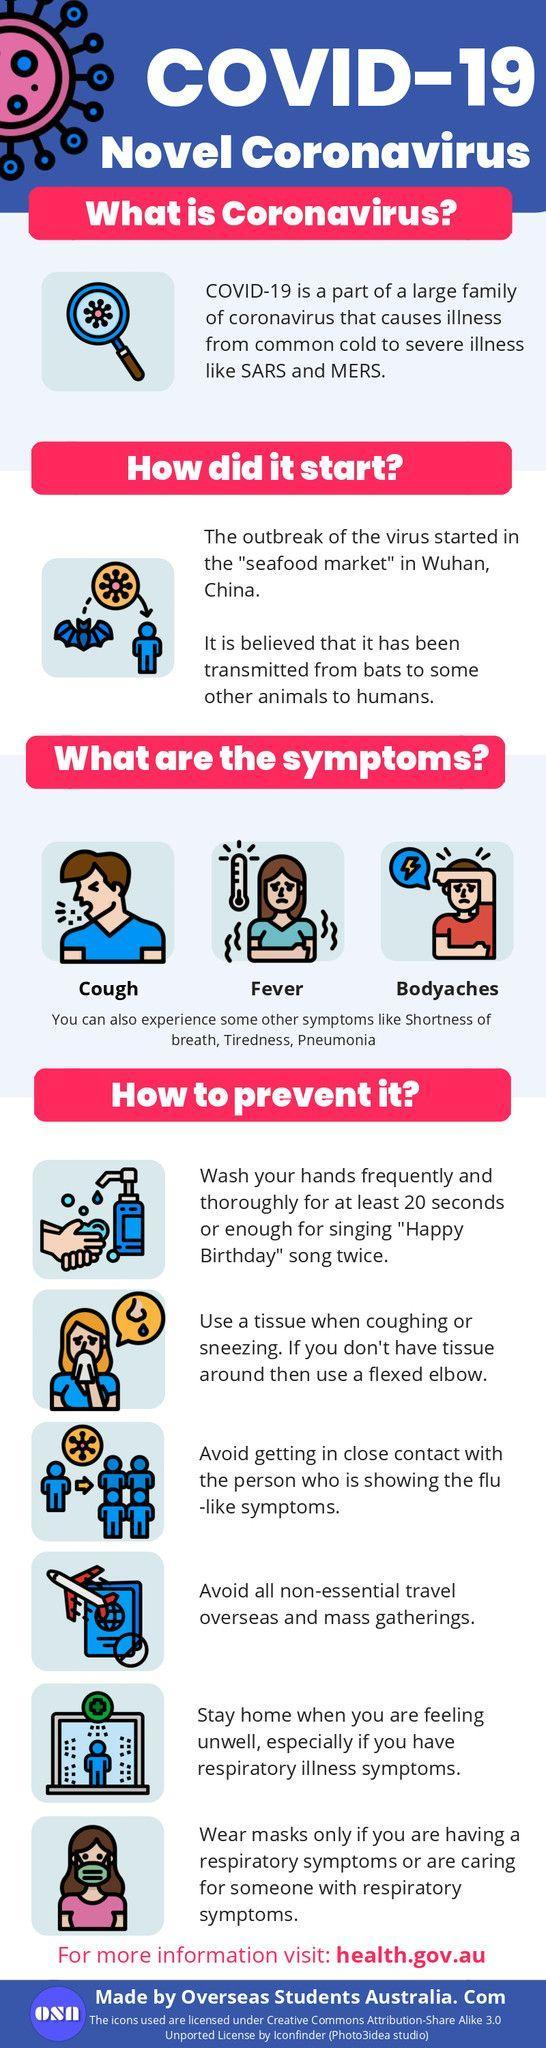How many symptoms are listed?
Answer the question with a short phrase. 6 